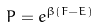Convert formula to latex. <formula><loc_0><loc_0><loc_500><loc_500>P = e ^ { \beta ( F - E ) }</formula> 